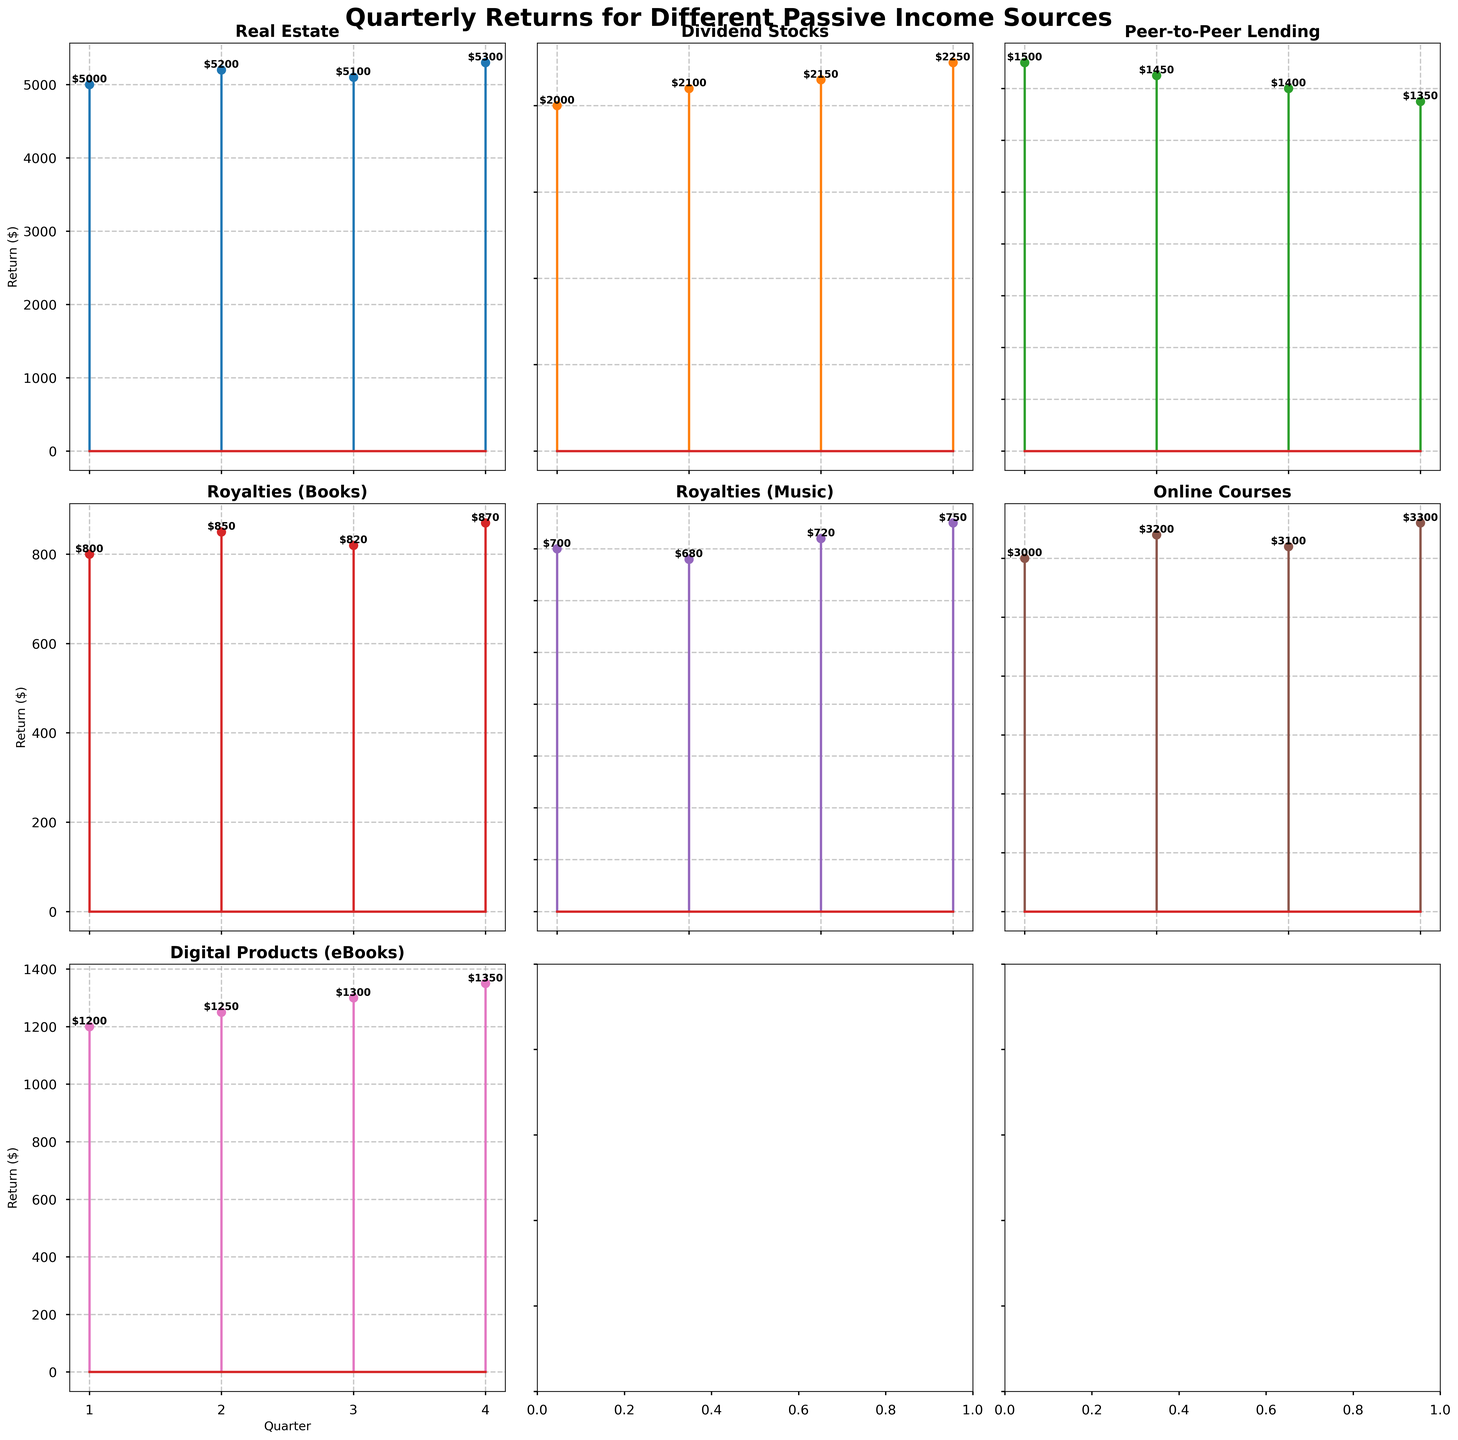What is the title of the figure? The title of the figure can be found at the top and reads "Quarterly Returns for Different Passive Income Sources".
Answer: Quarterly Returns for Different Passive Income Sources Which revenue stream had the highest return in Q4? By looking at the vertical values of the data points for each revenue stream in Q4, we see that Real Estate had the highest return with $5300.
Answer: Real Estate What is the average return for Online Courses over the four quarters? To find the average, add the returns for Online Courses in all four quarters (3000+3200+3100+3300) and divide by the number of quarters (4). The average is (3000+3200+3100+3300)/4 = 3150.
Answer: 3150 Compare the Q1 returns of Dividend Stocks and Peer-to-Peer Lending. Which one is higher and by how much? Dividend Stocks had a return of $2000 in Q1 whereas Peer-to-Peer Lending had $1500. The difference is 2000 - 1500 = $500, so Dividend Stocks are higher by $500.
Answer: Dividend Stocks by $500 Which revenue stream showed the most consistent returns across all four quarters? The revenue stream with the least fluctuation in returns is Peer-to-Peer Lending, with returns of 1500, 1450, 1400, and 1350, showing a small and steady decrease.
Answer: Peer-to-Peer Lending How did the returns for Digital Products (eBooks) change from Q1 to Q4? To determine the change, subtract the Q1 return from the Q4 return for Digital Products (eBooks). This is 1350 - 1200 = $150, so there is an increase of $150.
Answer: Increased by $150 What is the total return for Real Estate over all quarters? To find the total return, sum the returns for Real Estate across all quarters (5000 + 5200 + 5100 + 5300). The total is 5000 + 5200 + 5100 + 5300 = $20600.
Answer: $20600 Which revenue streams experienced a decrease in returns from Q1 to Q2? Examining each subplot, Peer-to-Peer Lending and Royalties (Music) both had decreases from Q1 to Q2. Peer-to-Peer Lending went from $1500 to $1450, and Royalties (Music) went from $700 to $680.
Answer: Peer-to-Peer Lending and Royalties (Music) For which revenue stream does Q3 have the highest return compared to the other quarters? Compare the Q3 return with the other quarters for each revenue stream. For Dividend Stocks, Q3's return ($2150) is higher compared to Q1 ($2000), Q2 ($2100), and Q4 ($2250), making it not the highest. Online Courses in Q3 have a return of $3100, but it's not the highest among its other quarters either. The revenue stream that fits the criteria is Royalties (Music) with a higher Q3 return ($720) compared to Q1, Q2, and Q4.
Answer: Royalties (Music) 